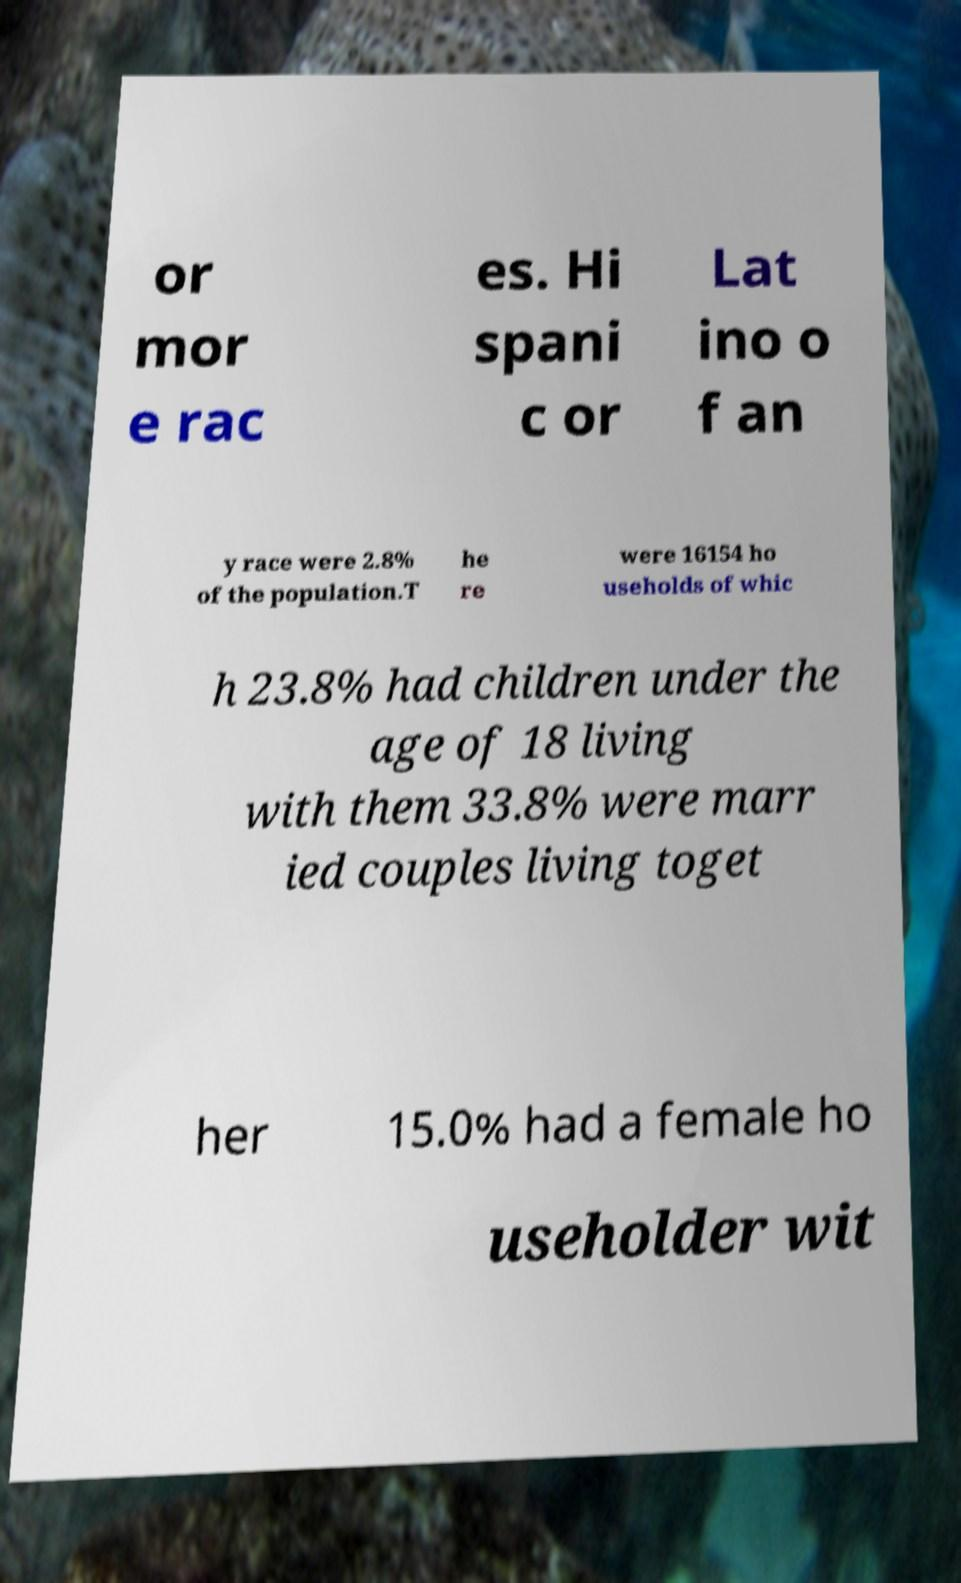Can you accurately transcribe the text from the provided image for me? or mor e rac es. Hi spani c or Lat ino o f an y race were 2.8% of the population.T he re were 16154 ho useholds of whic h 23.8% had children under the age of 18 living with them 33.8% were marr ied couples living toget her 15.0% had a female ho useholder wit 